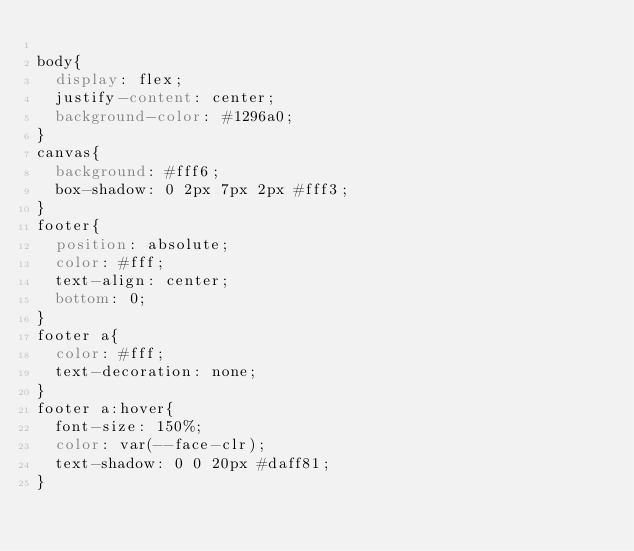<code> <loc_0><loc_0><loc_500><loc_500><_CSS_>
body{
  display: flex;
  justify-content: center;
  background-color: #1296a0;
}
canvas{
  background: #fff6;
  box-shadow: 0 2px 7px 2px #fff3;
}
footer{
  position: absolute;
  color: #fff;
  text-align: center;
  bottom: 0;
}
footer a{
  color: #fff;
  text-decoration: none;
}
footer a:hover{
  font-size: 150%;
  color: var(--face-clr);
  text-shadow: 0 0 20px #daff81;
}</code> 